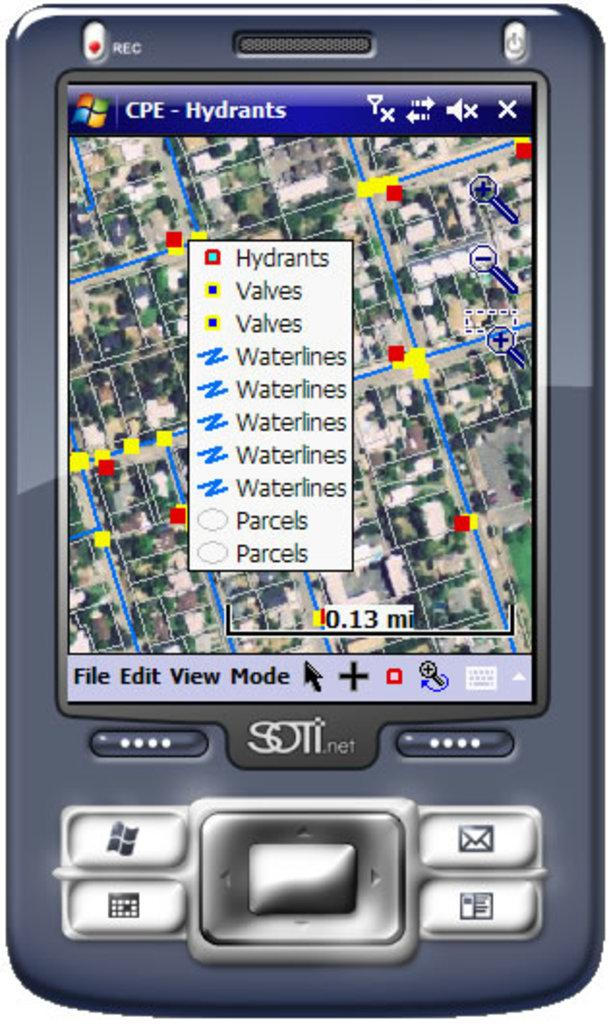<image>
Relay a brief, clear account of the picture shown. A wireless device shows a screen that says CPE-Hydrants and has a map that shows hydrants, valves, waterlines, and parcels. 